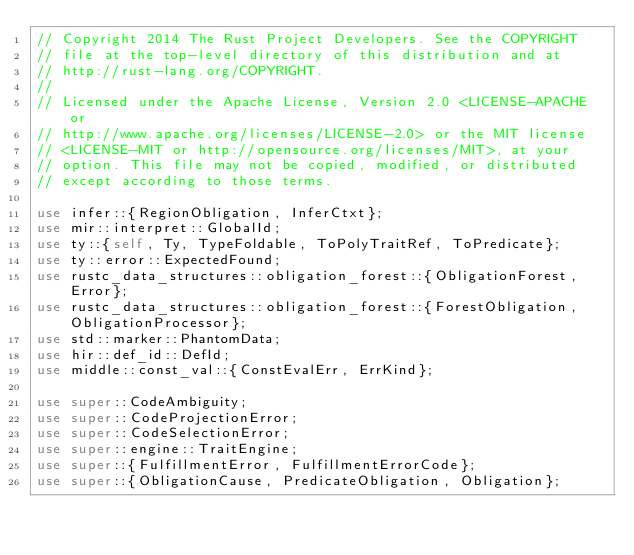Convert code to text. <code><loc_0><loc_0><loc_500><loc_500><_Rust_>// Copyright 2014 The Rust Project Developers. See the COPYRIGHT
// file at the top-level directory of this distribution and at
// http://rust-lang.org/COPYRIGHT.
//
// Licensed under the Apache License, Version 2.0 <LICENSE-APACHE or
// http://www.apache.org/licenses/LICENSE-2.0> or the MIT license
// <LICENSE-MIT or http://opensource.org/licenses/MIT>, at your
// option. This file may not be copied, modified, or distributed
// except according to those terms.

use infer::{RegionObligation, InferCtxt};
use mir::interpret::GlobalId;
use ty::{self, Ty, TypeFoldable, ToPolyTraitRef, ToPredicate};
use ty::error::ExpectedFound;
use rustc_data_structures::obligation_forest::{ObligationForest, Error};
use rustc_data_structures::obligation_forest::{ForestObligation, ObligationProcessor};
use std::marker::PhantomData;
use hir::def_id::DefId;
use middle::const_val::{ConstEvalErr, ErrKind};

use super::CodeAmbiguity;
use super::CodeProjectionError;
use super::CodeSelectionError;
use super::engine::TraitEngine;
use super::{FulfillmentError, FulfillmentErrorCode};
use super::{ObligationCause, PredicateObligation, Obligation};</code> 